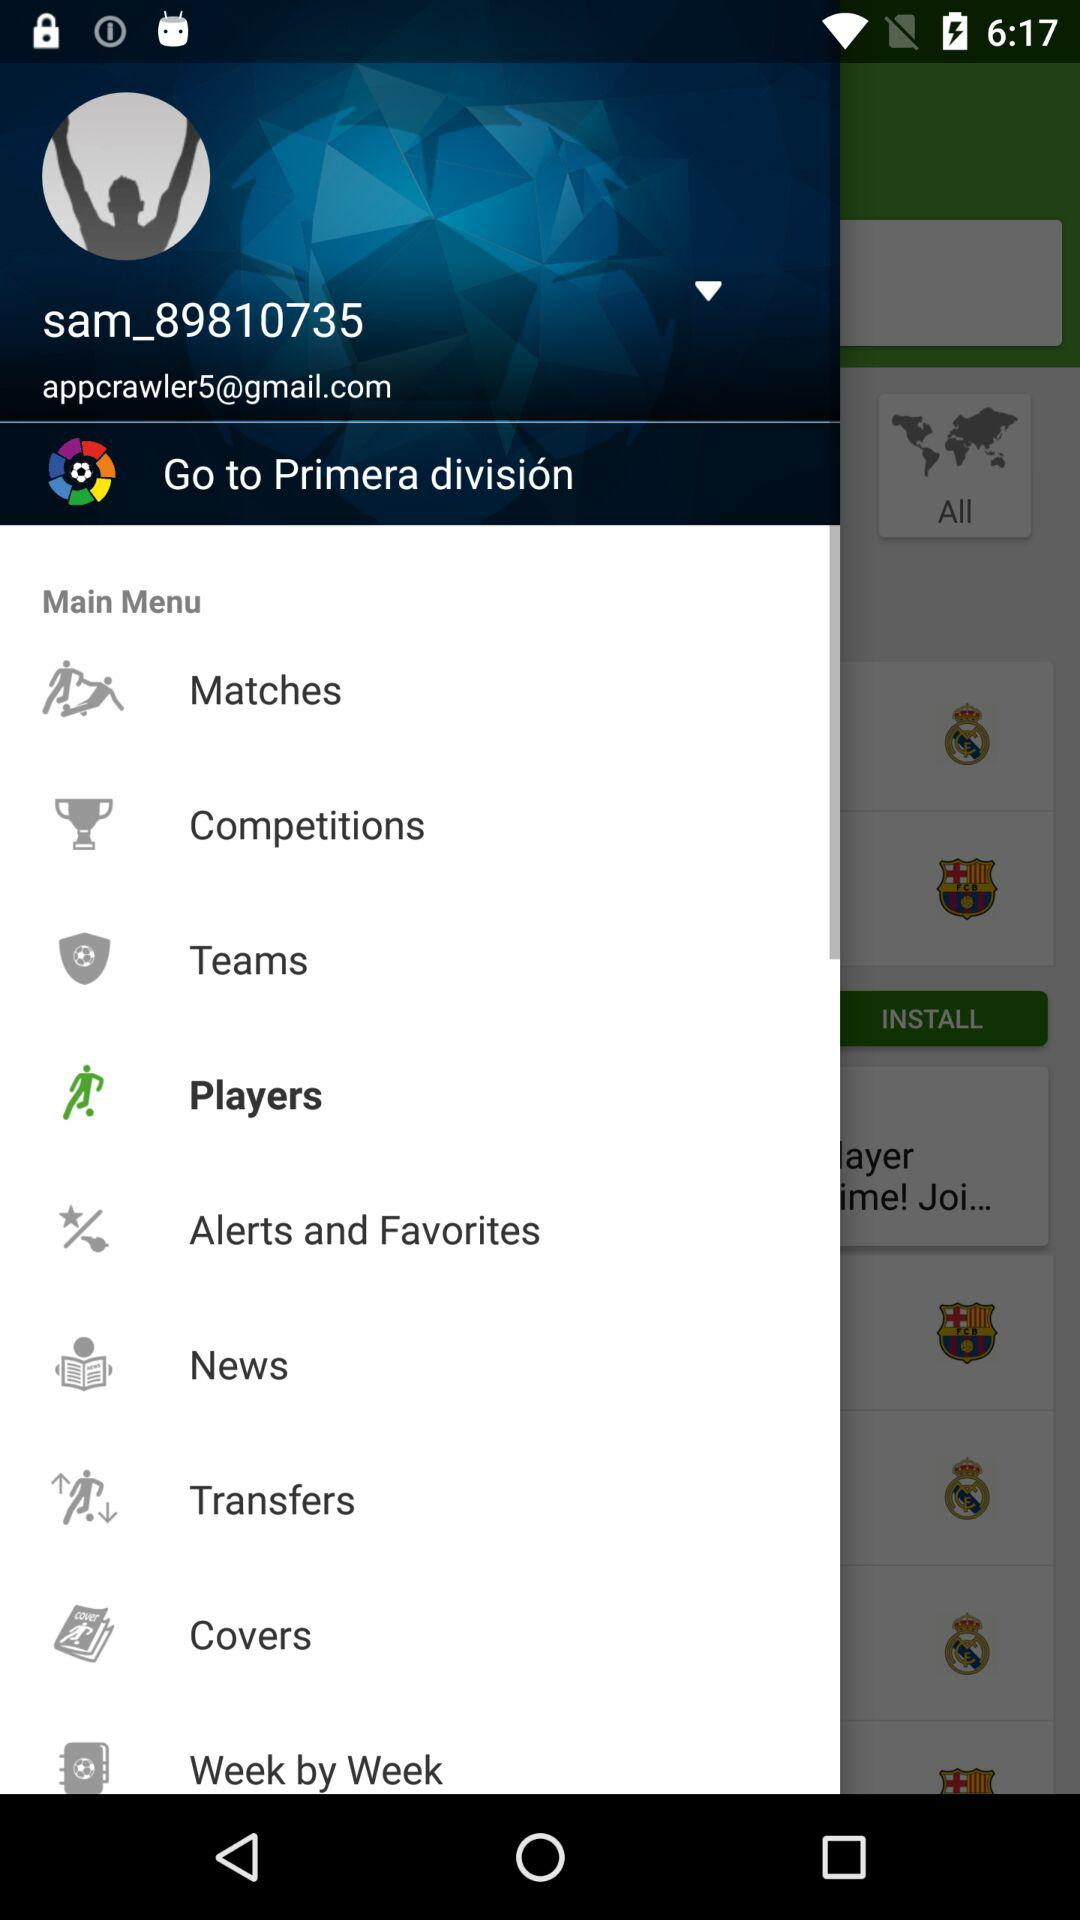Which item is selected in the menu? The selected item in the menu is "Players". 